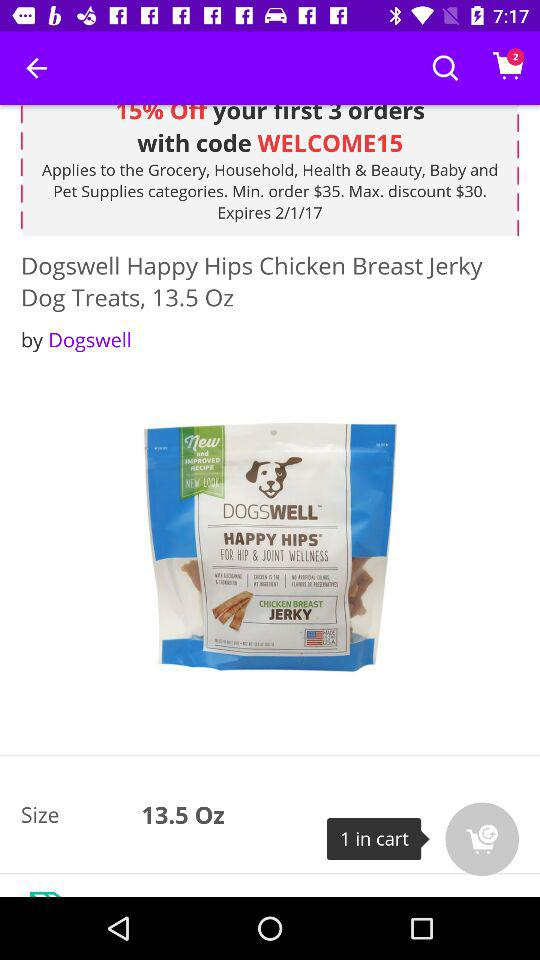How many ounces are the dog treats?
Answer the question using a single word or phrase. 13.5 